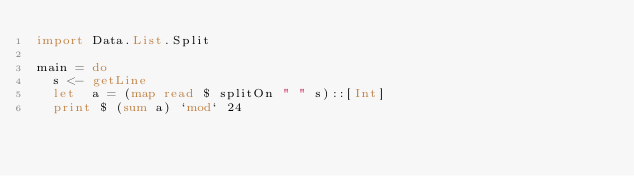Convert code to text. <code><loc_0><loc_0><loc_500><loc_500><_Haskell_>import Data.List.Split

main = do
  s <- getLine
  let  a = (map read $ splitOn " " s)::[Int]
  print $ (sum a) `mod` 24</code> 